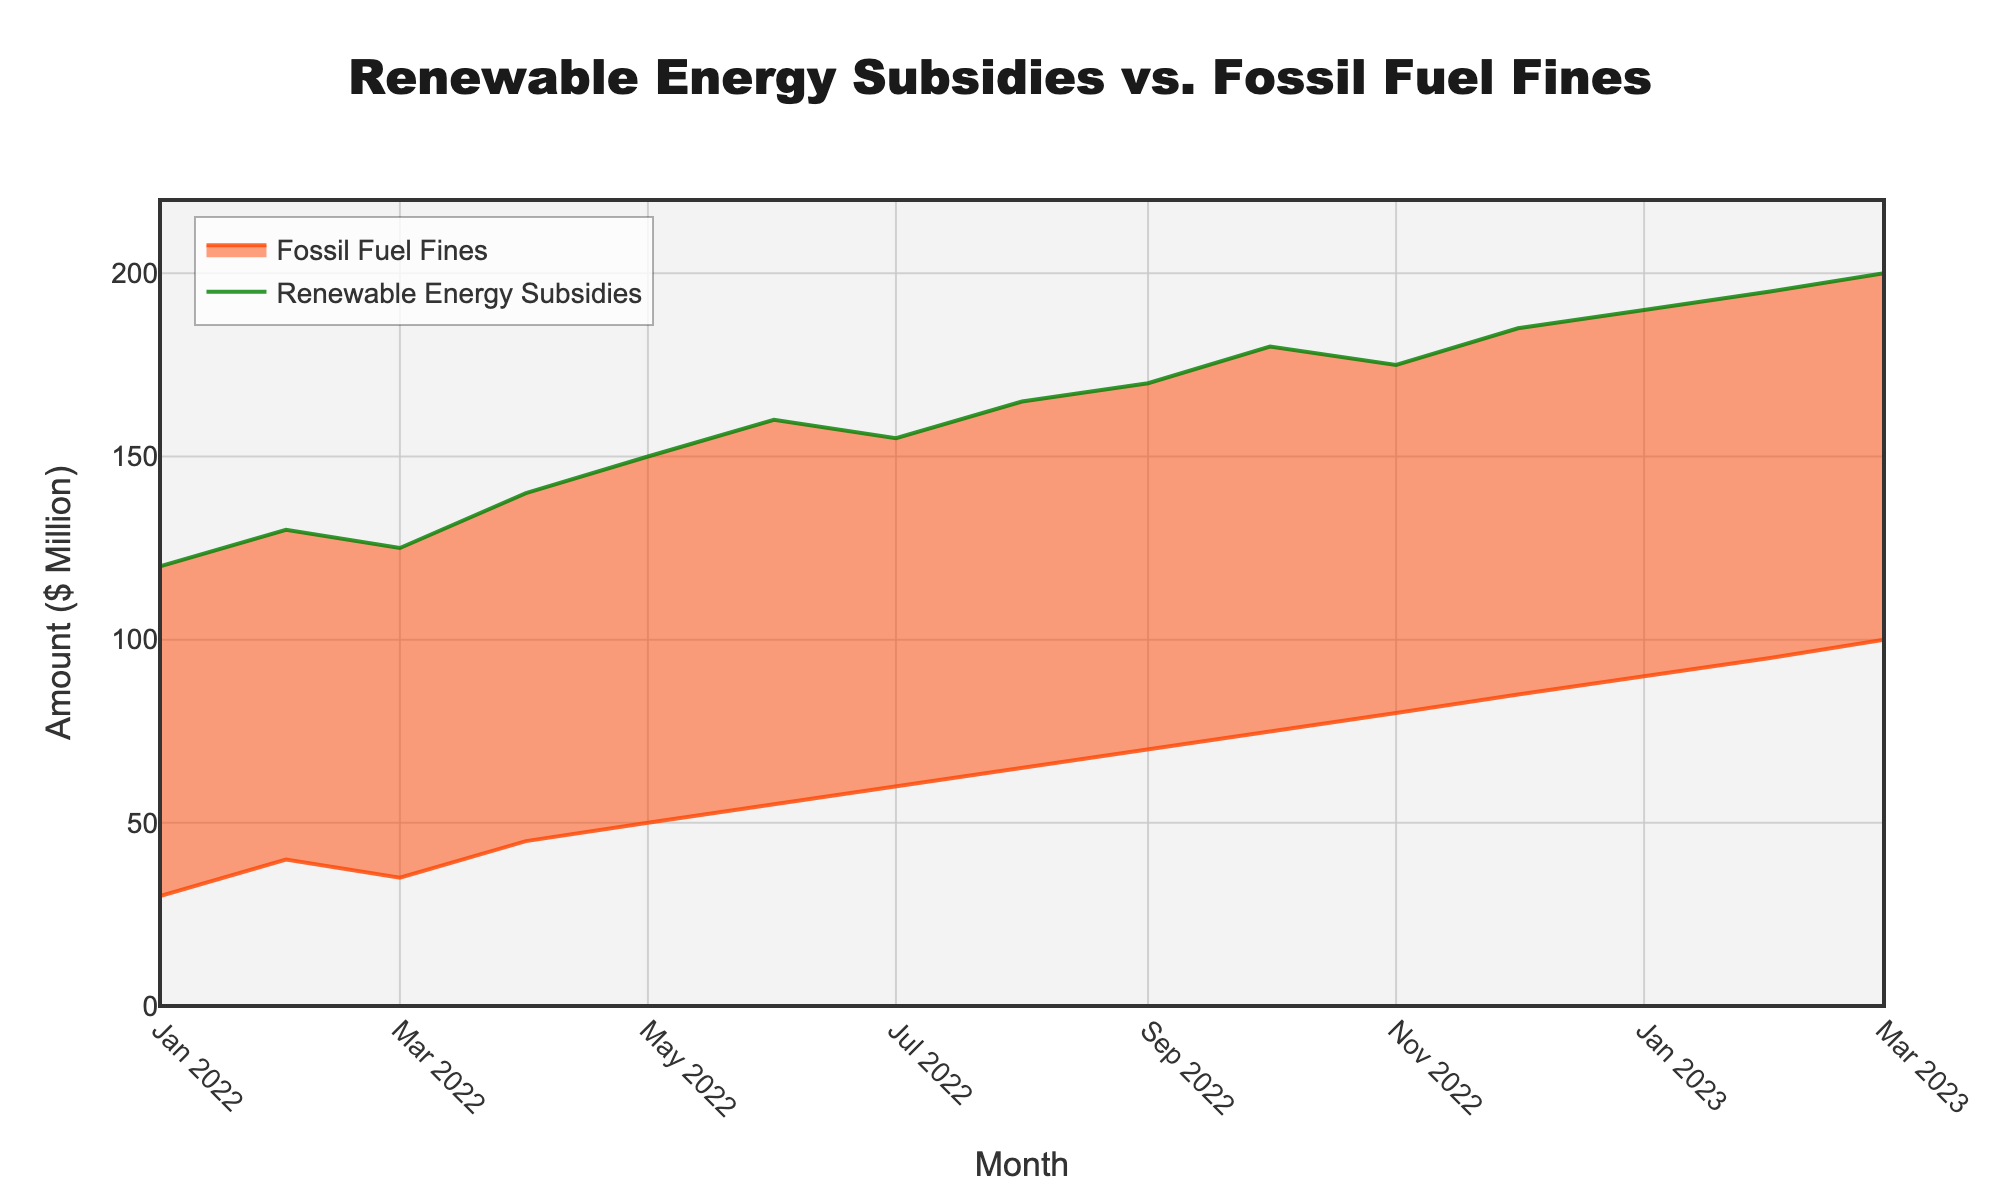What is the title of the chart? The title of the chart is usually displayed prominently at the top. For this figure, it is clearly stated as 'Renewable Energy Subsidies vs. Fossil Fuel Fines'.
Answer: Renewable Energy Subsidies vs. Fossil Fuel Fines What are the units used on the y-axis? The y-axis of the chart indicates the amount of money in millions of dollars, as shown by the label next to the axis.
Answer: $ Million Which month has the highest subsidy for renewable energy? By examining the highest point of the green colored line, which represents renewable energy subsidies, the month with the highest subsidy can be identified. The highest point occurs in March 2023 with a subsidy of $200 million.
Answer: March 2023 How much were the fossil fuel fines in August 2022? Locate the orange colored line, which represents fossil fuel fines, and find the value for August 2022. The fines for that month were $65 million.
Answer: $65 million What is the difference between the subsidies for renewable energy and the fines for fossil fuel companies in January 2023? To find the difference, subtract the fines from the subsidies for January 2023. Subsidies were $190 million and fines were $90 million, so the difference is $100 million.
Answer: $100 million Which month shows the highest increase in renewable energy subsidies compared to the previous month? To determine this, compare the difference in subsidies month-over-month. The highest increase occurs between December 2022 ($185 million) and January 2023 ($190 million), an increase of $5 million.
Answer: January 2023 Are there any months where the fines for fossil fuel companies are equal to $50 million? Scan the points where the orange line intersects $50 million on the y-axis. This occurs in May 2022.
Answer: May 2022 How does the trend in subsidies for renewable energy compare to the trend in fines for fossil fuel companies over the time period shown? Review the overall direction of each line. Both the subsidies (green line) and the fines (orange line) show a generally increasing trend over the period from January 2022 to March 2023.
Answer: Both trends are increasing What is the sum of renewable energy subsidies for the entire period? Add up all the monthly subsidies to find the total. The sum is $120 + $130 + $125 + $140 + $150 + $160 + $155 + $165 + $170 + $180 + $175 + $185 + $190 + $195 + $200 = $2,440 million.
Answer: $2,440 million Which had a higher increase from January 2022 to March 2023, renewable energy subsidies or fossil fuel fines? Calculate the difference in values from January 2022 to March 2023 for both. Renewable energy subsidies increased from $120 million to $200 million (an increase of $80 million), and fossil fuel fines increased from $30 million to $100 million (an increase of $70 million). Thus, renewable energy subsidies had a higher increase.
Answer: Renewable energy subsidies 